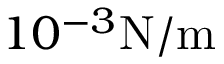Convert formula to latex. <formula><loc_0><loc_0><loc_500><loc_500>1 0 ^ { - 3 } { N / m }</formula> 